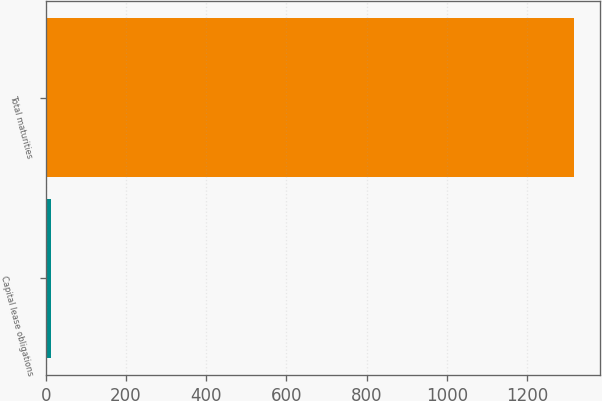<chart> <loc_0><loc_0><loc_500><loc_500><bar_chart><fcel>Capital lease obligations<fcel>Total maturities<nl><fcel>12<fcel>1316.7<nl></chart> 